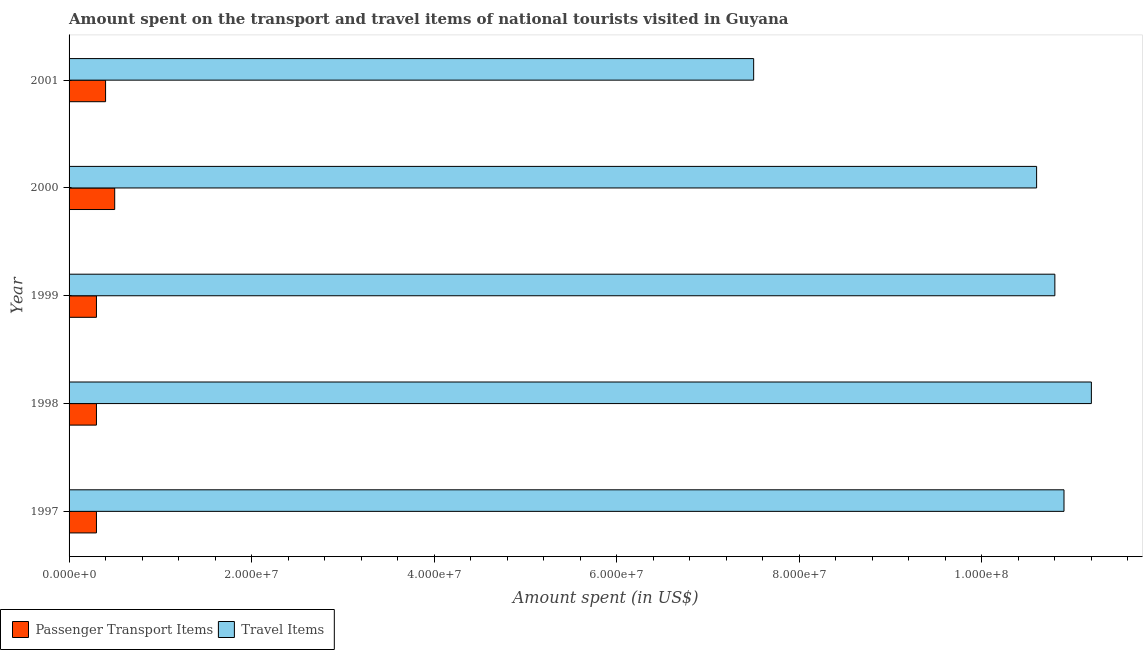How many groups of bars are there?
Your answer should be very brief. 5. How many bars are there on the 5th tick from the bottom?
Your response must be concise. 2. In how many cases, is the number of bars for a given year not equal to the number of legend labels?
Provide a succinct answer. 0. What is the amount spent on passenger transport items in 1999?
Give a very brief answer. 3.00e+06. Across all years, what is the maximum amount spent in travel items?
Offer a terse response. 1.12e+08. Across all years, what is the minimum amount spent in travel items?
Make the answer very short. 7.50e+07. What is the total amount spent in travel items in the graph?
Give a very brief answer. 5.10e+08. What is the difference between the amount spent in travel items in 2000 and that in 2001?
Keep it short and to the point. 3.10e+07. What is the difference between the amount spent in travel items in 1998 and the amount spent on passenger transport items in 2001?
Ensure brevity in your answer.  1.08e+08. What is the average amount spent in travel items per year?
Make the answer very short. 1.02e+08. In the year 1998, what is the difference between the amount spent on passenger transport items and amount spent in travel items?
Offer a terse response. -1.09e+08. In how many years, is the amount spent on passenger transport items greater than 12000000 US$?
Ensure brevity in your answer.  0. What is the ratio of the amount spent in travel items in 1998 to that in 2001?
Offer a very short reply. 1.49. What is the difference between the highest and the lowest amount spent on passenger transport items?
Make the answer very short. 2.00e+06. In how many years, is the amount spent on passenger transport items greater than the average amount spent on passenger transport items taken over all years?
Provide a succinct answer. 2. Is the sum of the amount spent on passenger transport items in 1999 and 2001 greater than the maximum amount spent in travel items across all years?
Your answer should be very brief. No. What does the 2nd bar from the top in 1999 represents?
Make the answer very short. Passenger Transport Items. What does the 1st bar from the bottom in 2000 represents?
Give a very brief answer. Passenger Transport Items. How many years are there in the graph?
Your answer should be very brief. 5. What is the difference between two consecutive major ticks on the X-axis?
Provide a succinct answer. 2.00e+07. Does the graph contain any zero values?
Offer a very short reply. No. Does the graph contain grids?
Give a very brief answer. No. How are the legend labels stacked?
Make the answer very short. Horizontal. What is the title of the graph?
Your answer should be very brief. Amount spent on the transport and travel items of national tourists visited in Guyana. Does "Mineral" appear as one of the legend labels in the graph?
Make the answer very short. No. What is the label or title of the X-axis?
Make the answer very short. Amount spent (in US$). What is the label or title of the Y-axis?
Your answer should be compact. Year. What is the Amount spent (in US$) in Passenger Transport Items in 1997?
Give a very brief answer. 3.00e+06. What is the Amount spent (in US$) in Travel Items in 1997?
Provide a short and direct response. 1.09e+08. What is the Amount spent (in US$) of Passenger Transport Items in 1998?
Ensure brevity in your answer.  3.00e+06. What is the Amount spent (in US$) of Travel Items in 1998?
Provide a short and direct response. 1.12e+08. What is the Amount spent (in US$) in Passenger Transport Items in 1999?
Offer a terse response. 3.00e+06. What is the Amount spent (in US$) of Travel Items in 1999?
Keep it short and to the point. 1.08e+08. What is the Amount spent (in US$) in Passenger Transport Items in 2000?
Ensure brevity in your answer.  5.00e+06. What is the Amount spent (in US$) of Travel Items in 2000?
Your answer should be very brief. 1.06e+08. What is the Amount spent (in US$) of Passenger Transport Items in 2001?
Offer a very short reply. 4.00e+06. What is the Amount spent (in US$) in Travel Items in 2001?
Provide a short and direct response. 7.50e+07. Across all years, what is the maximum Amount spent (in US$) of Passenger Transport Items?
Ensure brevity in your answer.  5.00e+06. Across all years, what is the maximum Amount spent (in US$) of Travel Items?
Keep it short and to the point. 1.12e+08. Across all years, what is the minimum Amount spent (in US$) of Passenger Transport Items?
Provide a short and direct response. 3.00e+06. Across all years, what is the minimum Amount spent (in US$) in Travel Items?
Offer a very short reply. 7.50e+07. What is the total Amount spent (in US$) in Passenger Transport Items in the graph?
Give a very brief answer. 1.80e+07. What is the total Amount spent (in US$) of Travel Items in the graph?
Make the answer very short. 5.10e+08. What is the difference between the Amount spent (in US$) of Passenger Transport Items in 1997 and that in 1998?
Make the answer very short. 0. What is the difference between the Amount spent (in US$) of Travel Items in 1997 and that in 1998?
Ensure brevity in your answer.  -3.00e+06. What is the difference between the Amount spent (in US$) of Travel Items in 1997 and that in 2000?
Your answer should be very brief. 3.00e+06. What is the difference between the Amount spent (in US$) in Travel Items in 1997 and that in 2001?
Your response must be concise. 3.40e+07. What is the difference between the Amount spent (in US$) of Travel Items in 1998 and that in 1999?
Provide a succinct answer. 4.00e+06. What is the difference between the Amount spent (in US$) in Travel Items in 1998 and that in 2000?
Keep it short and to the point. 6.00e+06. What is the difference between the Amount spent (in US$) in Passenger Transport Items in 1998 and that in 2001?
Provide a short and direct response. -1.00e+06. What is the difference between the Amount spent (in US$) of Travel Items in 1998 and that in 2001?
Offer a very short reply. 3.70e+07. What is the difference between the Amount spent (in US$) of Passenger Transport Items in 1999 and that in 2000?
Your answer should be compact. -2.00e+06. What is the difference between the Amount spent (in US$) of Travel Items in 1999 and that in 2001?
Offer a terse response. 3.30e+07. What is the difference between the Amount spent (in US$) of Passenger Transport Items in 2000 and that in 2001?
Your answer should be very brief. 1.00e+06. What is the difference between the Amount spent (in US$) of Travel Items in 2000 and that in 2001?
Ensure brevity in your answer.  3.10e+07. What is the difference between the Amount spent (in US$) of Passenger Transport Items in 1997 and the Amount spent (in US$) of Travel Items in 1998?
Ensure brevity in your answer.  -1.09e+08. What is the difference between the Amount spent (in US$) of Passenger Transport Items in 1997 and the Amount spent (in US$) of Travel Items in 1999?
Offer a very short reply. -1.05e+08. What is the difference between the Amount spent (in US$) of Passenger Transport Items in 1997 and the Amount spent (in US$) of Travel Items in 2000?
Offer a terse response. -1.03e+08. What is the difference between the Amount spent (in US$) of Passenger Transport Items in 1997 and the Amount spent (in US$) of Travel Items in 2001?
Keep it short and to the point. -7.20e+07. What is the difference between the Amount spent (in US$) of Passenger Transport Items in 1998 and the Amount spent (in US$) of Travel Items in 1999?
Keep it short and to the point. -1.05e+08. What is the difference between the Amount spent (in US$) of Passenger Transport Items in 1998 and the Amount spent (in US$) of Travel Items in 2000?
Offer a terse response. -1.03e+08. What is the difference between the Amount spent (in US$) in Passenger Transport Items in 1998 and the Amount spent (in US$) in Travel Items in 2001?
Provide a short and direct response. -7.20e+07. What is the difference between the Amount spent (in US$) in Passenger Transport Items in 1999 and the Amount spent (in US$) in Travel Items in 2000?
Your answer should be compact. -1.03e+08. What is the difference between the Amount spent (in US$) in Passenger Transport Items in 1999 and the Amount spent (in US$) in Travel Items in 2001?
Keep it short and to the point. -7.20e+07. What is the difference between the Amount spent (in US$) in Passenger Transport Items in 2000 and the Amount spent (in US$) in Travel Items in 2001?
Keep it short and to the point. -7.00e+07. What is the average Amount spent (in US$) in Passenger Transport Items per year?
Ensure brevity in your answer.  3.60e+06. What is the average Amount spent (in US$) in Travel Items per year?
Your answer should be compact. 1.02e+08. In the year 1997, what is the difference between the Amount spent (in US$) of Passenger Transport Items and Amount spent (in US$) of Travel Items?
Give a very brief answer. -1.06e+08. In the year 1998, what is the difference between the Amount spent (in US$) in Passenger Transport Items and Amount spent (in US$) in Travel Items?
Your answer should be very brief. -1.09e+08. In the year 1999, what is the difference between the Amount spent (in US$) in Passenger Transport Items and Amount spent (in US$) in Travel Items?
Give a very brief answer. -1.05e+08. In the year 2000, what is the difference between the Amount spent (in US$) in Passenger Transport Items and Amount spent (in US$) in Travel Items?
Make the answer very short. -1.01e+08. In the year 2001, what is the difference between the Amount spent (in US$) of Passenger Transport Items and Amount spent (in US$) of Travel Items?
Your answer should be very brief. -7.10e+07. What is the ratio of the Amount spent (in US$) of Travel Items in 1997 to that in 1998?
Provide a succinct answer. 0.97. What is the ratio of the Amount spent (in US$) in Passenger Transport Items in 1997 to that in 1999?
Your answer should be compact. 1. What is the ratio of the Amount spent (in US$) of Travel Items in 1997 to that in 1999?
Your answer should be compact. 1.01. What is the ratio of the Amount spent (in US$) in Passenger Transport Items in 1997 to that in 2000?
Your answer should be compact. 0.6. What is the ratio of the Amount spent (in US$) in Travel Items in 1997 to that in 2000?
Your answer should be compact. 1.03. What is the ratio of the Amount spent (in US$) in Travel Items in 1997 to that in 2001?
Provide a short and direct response. 1.45. What is the ratio of the Amount spent (in US$) of Passenger Transport Items in 1998 to that in 1999?
Ensure brevity in your answer.  1. What is the ratio of the Amount spent (in US$) in Travel Items in 1998 to that in 2000?
Give a very brief answer. 1.06. What is the ratio of the Amount spent (in US$) in Travel Items in 1998 to that in 2001?
Your response must be concise. 1.49. What is the ratio of the Amount spent (in US$) of Travel Items in 1999 to that in 2000?
Provide a succinct answer. 1.02. What is the ratio of the Amount spent (in US$) of Passenger Transport Items in 1999 to that in 2001?
Give a very brief answer. 0.75. What is the ratio of the Amount spent (in US$) in Travel Items in 1999 to that in 2001?
Provide a short and direct response. 1.44. What is the ratio of the Amount spent (in US$) in Travel Items in 2000 to that in 2001?
Give a very brief answer. 1.41. What is the difference between the highest and the second highest Amount spent (in US$) in Passenger Transport Items?
Provide a short and direct response. 1.00e+06. What is the difference between the highest and the second highest Amount spent (in US$) of Travel Items?
Your answer should be compact. 3.00e+06. What is the difference between the highest and the lowest Amount spent (in US$) in Travel Items?
Your answer should be very brief. 3.70e+07. 